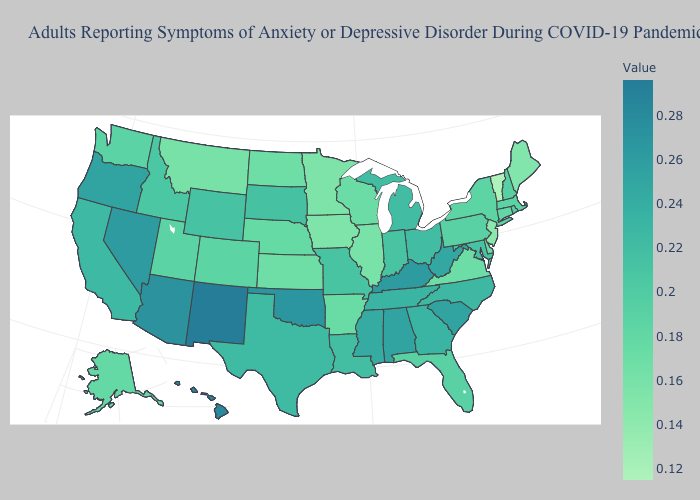Is the legend a continuous bar?
Concise answer only. Yes. Does the map have missing data?
Quick response, please. No. Among the states that border Michigan , which have the highest value?
Give a very brief answer. Ohio. Among the states that border Oklahoma , does Colorado have the highest value?
Answer briefly. No. Among the states that border New Mexico , which have the lowest value?
Keep it brief. Colorado. 